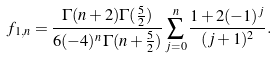<formula> <loc_0><loc_0><loc_500><loc_500>f _ { 1 , n } = \frac { \Gamma ( n + 2 ) \Gamma ( \frac { 5 } { 2 } ) } { 6 ( - 4 ) ^ { n } \Gamma ( n + \frac { 5 } { 2 } ) } \sum _ { j = 0 } ^ { n } \frac { 1 + 2 ( - 1 ) ^ { j } } { ( j + 1 ) ^ { 2 } } .</formula> 